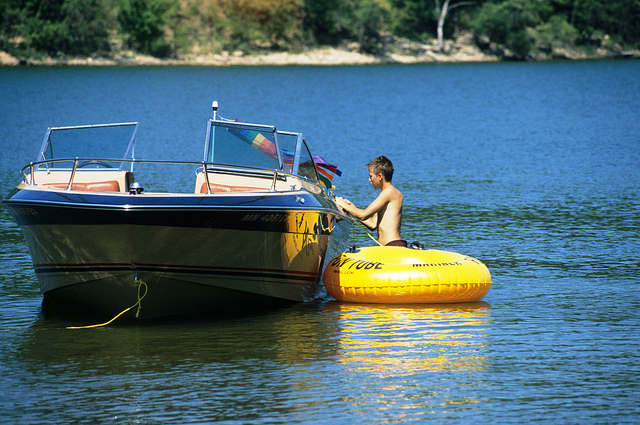<image>What supplies does the boat have? There are no supplies on the boat. However, it can be seen as a tube, float, or umbrella. What supplies does the boat have? I don't know what supplies the boat has. It can have a tube, float, raft and tie down, inner tube, umbrella, or tubing supplies. 